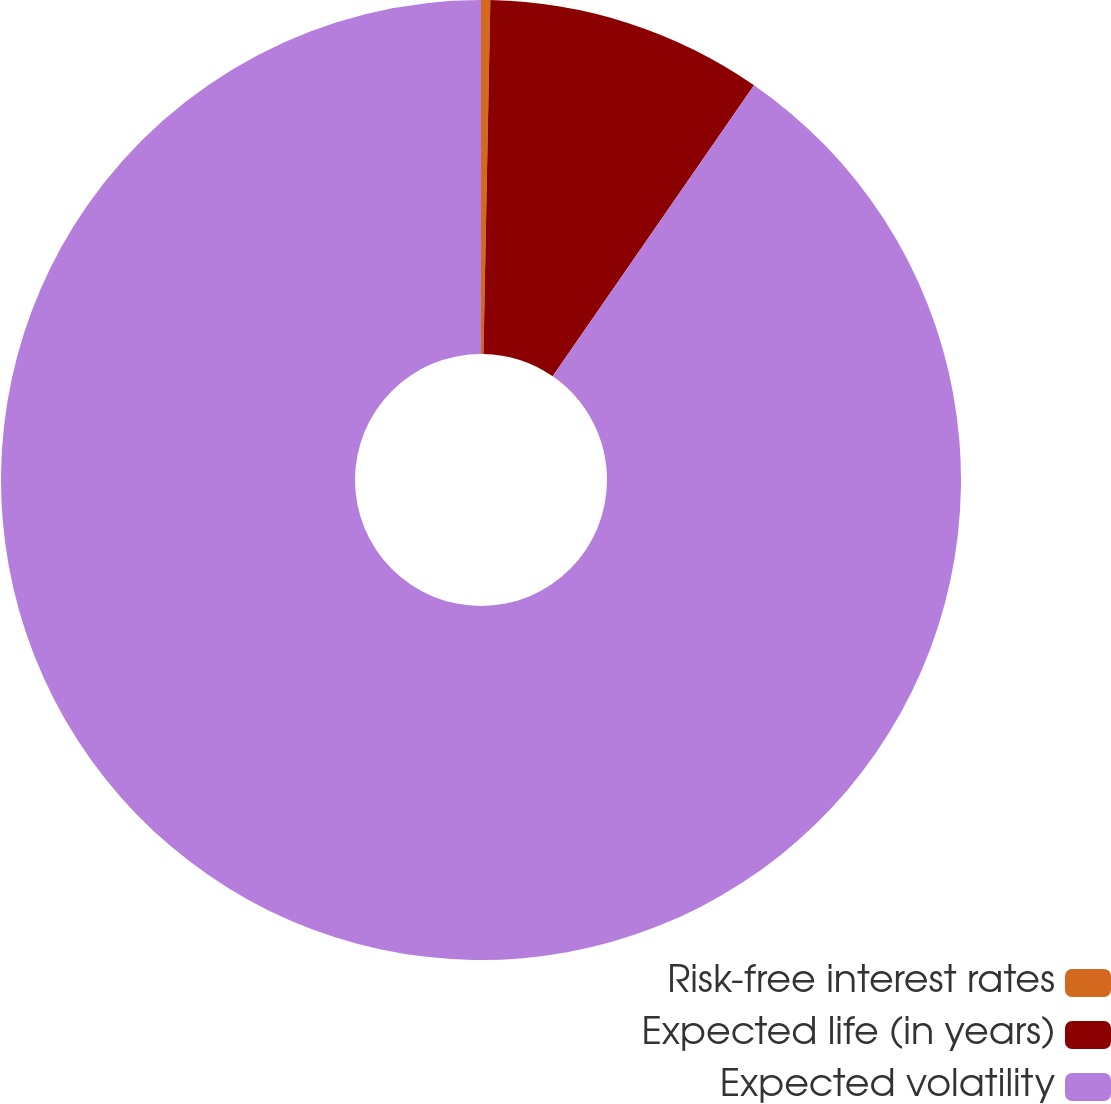Convert chart to OTSL. <chart><loc_0><loc_0><loc_500><loc_500><pie_chart><fcel>Risk-free interest rates<fcel>Expected life (in years)<fcel>Expected volatility<nl><fcel>0.31%<fcel>9.32%<fcel>90.37%<nl></chart> 